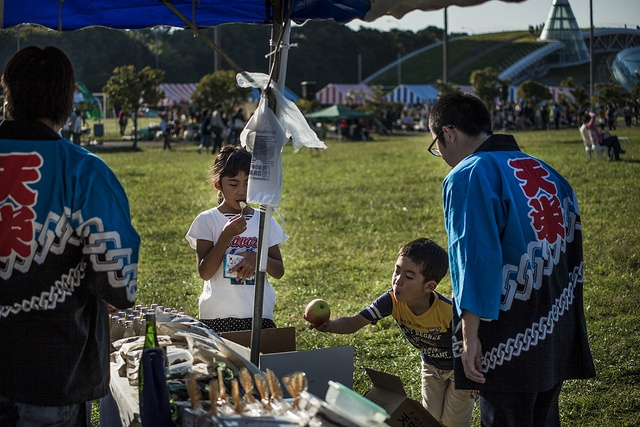Describe the objects in this image and their specific colors. I can see people in black, navy, gray, and maroon tones, people in black, navy, maroon, and gray tones, umbrella in black, navy, gray, and darkgray tones, people in black, darkgray, maroon, and gray tones, and people in black and gray tones in this image. 